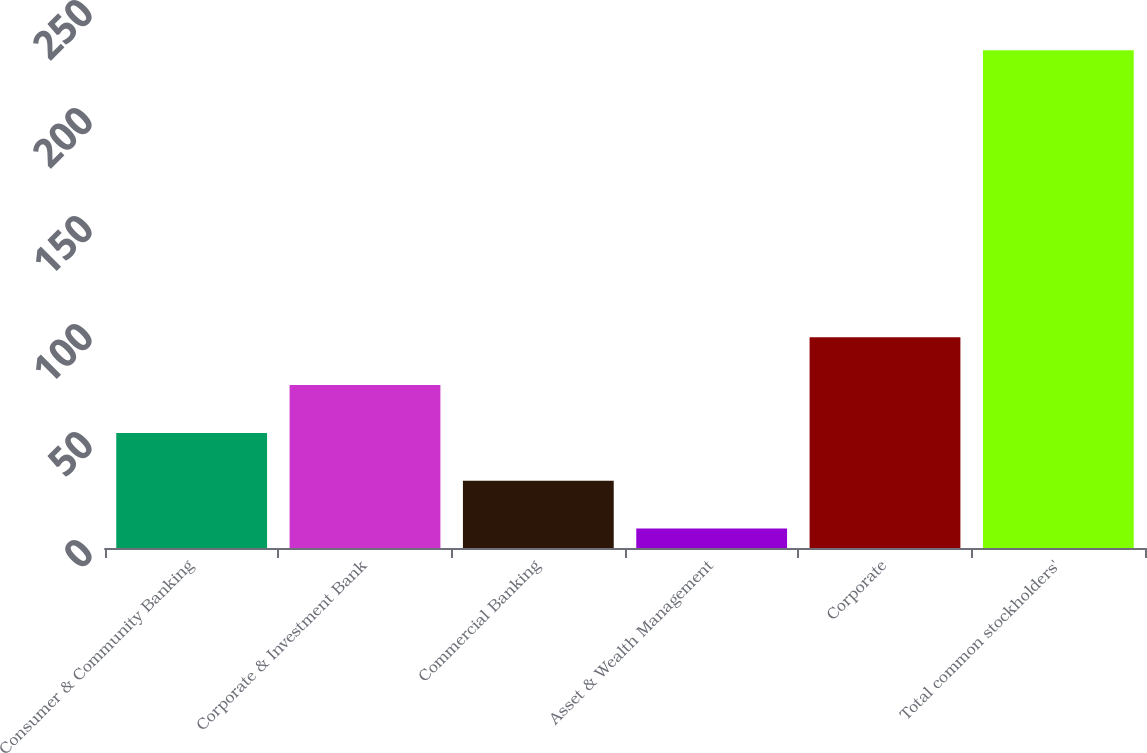Convert chart. <chart><loc_0><loc_0><loc_500><loc_500><bar_chart><fcel>Consumer & Community Banking<fcel>Corporate & Investment Bank<fcel>Commercial Banking<fcel>Asset & Wealth Management<fcel>Corporate<fcel>Total common stockholders'<nl><fcel>53.28<fcel>75.42<fcel>31.14<fcel>9<fcel>97.56<fcel>230.4<nl></chart> 